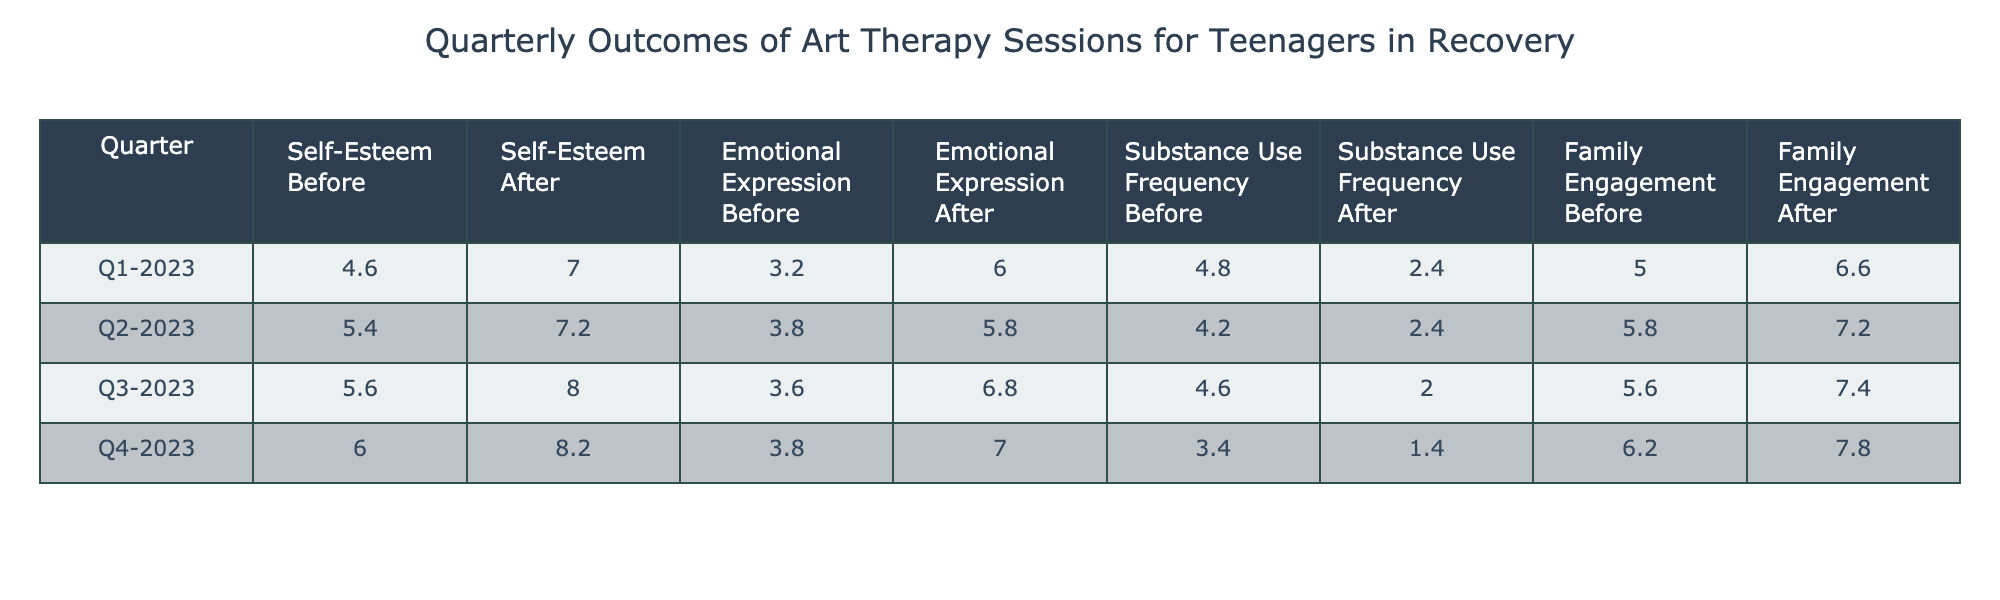What is the average Self-Esteem Rating After therapy in Q2-2023? To find the average Self-Esteem Rating After therapy in Q2-2023, I look at the values under the 'Self-Esteem Rating After' column for Q2-2023: (6 + 6 + 9 + 6 + 8) = 35. There are 5 participants, so the average is 35 / 5 = 7.
Answer: 7 What was the emotional expression score after therapy in Q3-2023 for Participant_ID 102? I can find the Emotional Expression Score After for Participant_ID 102 in the Q3-2023 row. The score is listed as 6.
Answer: 6 Did the Family Engagement Score improve from before to after therapy for all participants in Q4-2023? To answer this, I check the Family Engagement Score Before and After for each participant in Q4-2023. Participant IDs show: 8 (before) vs 9 (after), 5 (before) vs 7 (after), 6 (before) vs 8 (after), 4 (before) vs 6 (after), and 8 (before) vs 9 (after). All scores improved.
Answer: Yes What is the total change in Substance Use Frequency from Before to After therapy for participants in Q1-2023? I calculate the total change by summing the differences of Substance Use Frequency After and Before for each participant: (1-3) + (4-5) + (2-7) + (3-5) + (2-4) = -2 -1 -5 -2 -2 = -12. The total change is -12, indicating a reduction in substance use.
Answer: -12 What is the average Emotional Expression Score Before therapy across all quarters? I first calculate the average Emotional Expression Score Before for all quarters. The scores are: Q1 (3 + 4 + 3 + 2 + 4) = 16; Q2 (4 + 3 + 5 + 3 + 4) = 19; Q3 (4 + 3 + 5 + 2 + 4) = 18; Q4 (5 + 3 + 4 + 2 + 5) = 19. Adding the scores gives 16 + 19 + 18 + 19 = 72. Dividing by the total number of data points (20) gives an average of 72 / 20 = 3.6.
Answer: 3.6 Which therapy technique had the highest average Self-Esteem Rating After for Q1-2023? I look at the Self-Esteem Rating After for each therapy technique in Q1-2023: Painting (6), Collage (7), Sculpture (8), Drawing (5), Digital Art (9). The highest average is from Digital Art at 9.
Answer: Digital Art For which quarter did the participation show the most significant increase in Family Engagement Score After therapy? I calculate the average Family Engagement Score After for each quarter. For Q1, the After scores average to (7+5+8+5+8)/5 = 6.6; Q2 averages (8+6+7+6+9)/5 = 7.2; Q3 gives (9+7+8+5+8)/5 = 7.4; Q4 results in (9+7+8+6+9)/5 = 7.8. The most significant increase was observed in Q4, which averaged the highest.
Answer: Q4-2023 What was the average duration of art therapy sessions in minutes across all quarters? I sum the duration of session minutes across all quarters and divide by the total sessions. Total minutes is (60 + 75 + 90 + 50 + 80 + 70 + 60 + 75 + 45 + 85 + 65 + 80 + 55 + 45 + 90) = 1085 minutes. There are 20 sessions, so 1085 / 20 = 54.25 minutes on average for each session.
Answer: 54.25 minutes How many participants had a Self-Esteem Rating of 8 or higher after therapy in Q3-2023? I check the Self-Esteem Ratings After in Q3-2023: Participants 101 (8), 102 (8), 103 (9), 104 (6), 105 (9). Three participants scored 8 or higher.
Answer: 3 